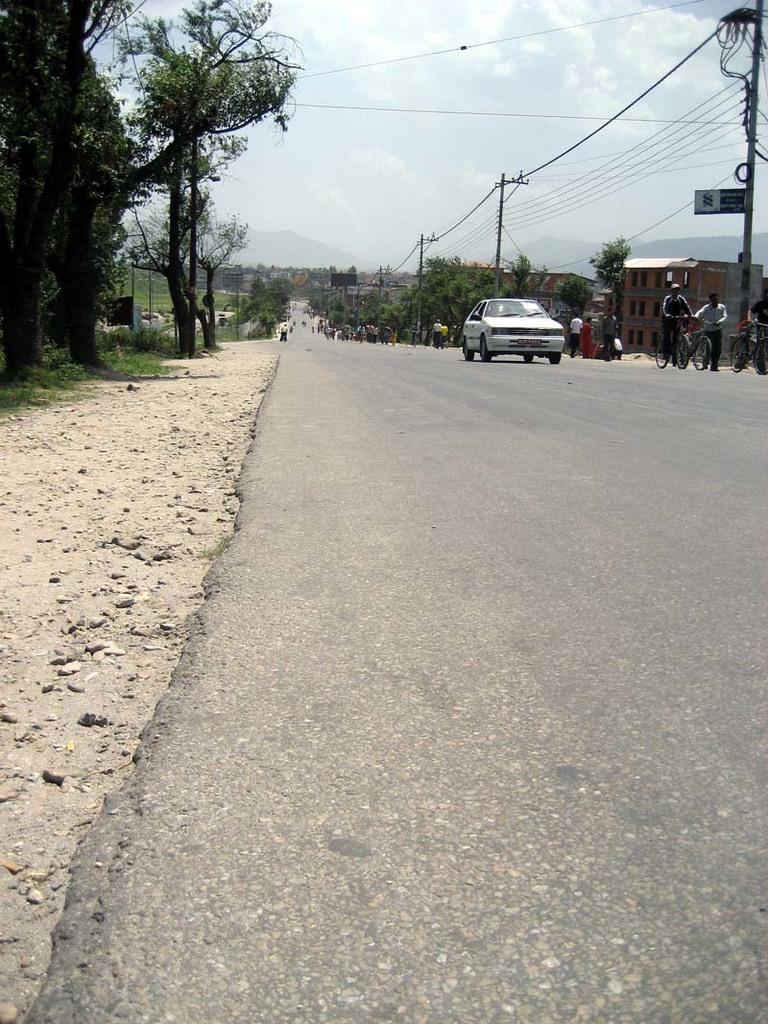What types of objects can be seen in the image? There are vehicles, people, poles, trees, wires, buildings, and objects in the image. Can you describe the setting of the image? The image features a road with vehicles and people, surrounded by poles, trees, and buildings. There are also wires visible, and mountains can be seen in the background. The sky is visible in the background as well. How many women are playing baseball in the image? There are no women playing baseball in the image. What type of calendar is hanging on the wall in the image? There is no calendar present in the image. 